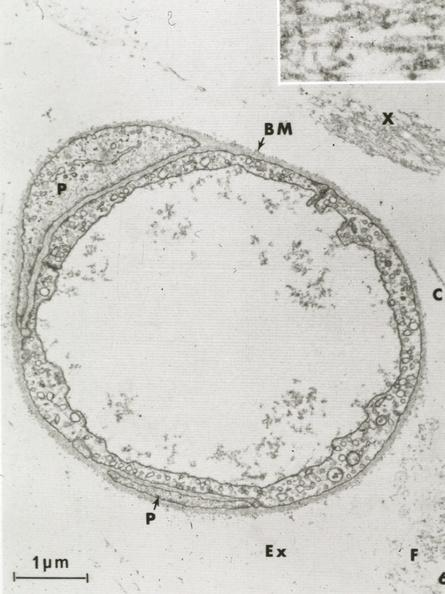what is present?
Answer the question using a single word or phrase. Capillary 